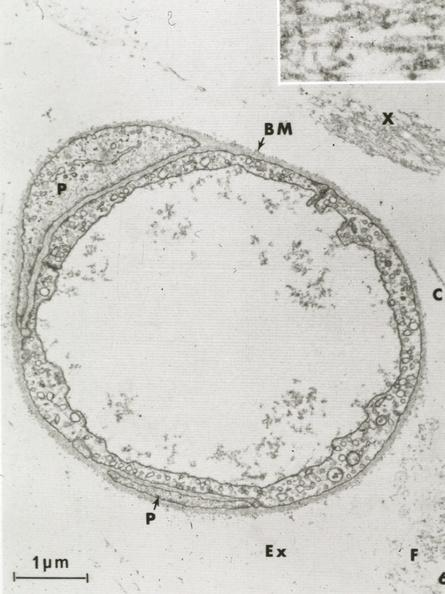what is present?
Answer the question using a single word or phrase. Capillary 